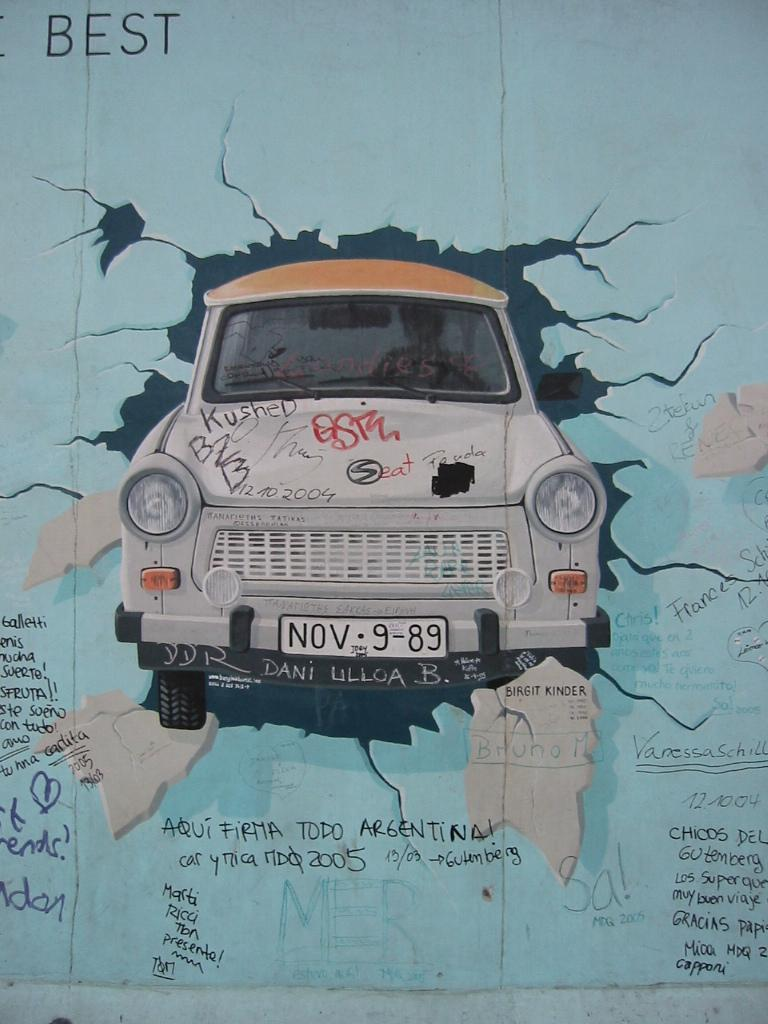What is the main subject of the image? The main subject of the image is a photo of a car. What feature can be seen on the car in the image? The car has a set of lights. Is there any text present on the car in the image? Yes, there is some text on the car. How many plants are growing inside the tent in the image? There is no tent or plants present in the image; it features a photo of a car with a set of lights and some text. What type of number is written on the car in the image? There is no specific number mentioned in the facts provided, and the image only states that there is some text on the car. 